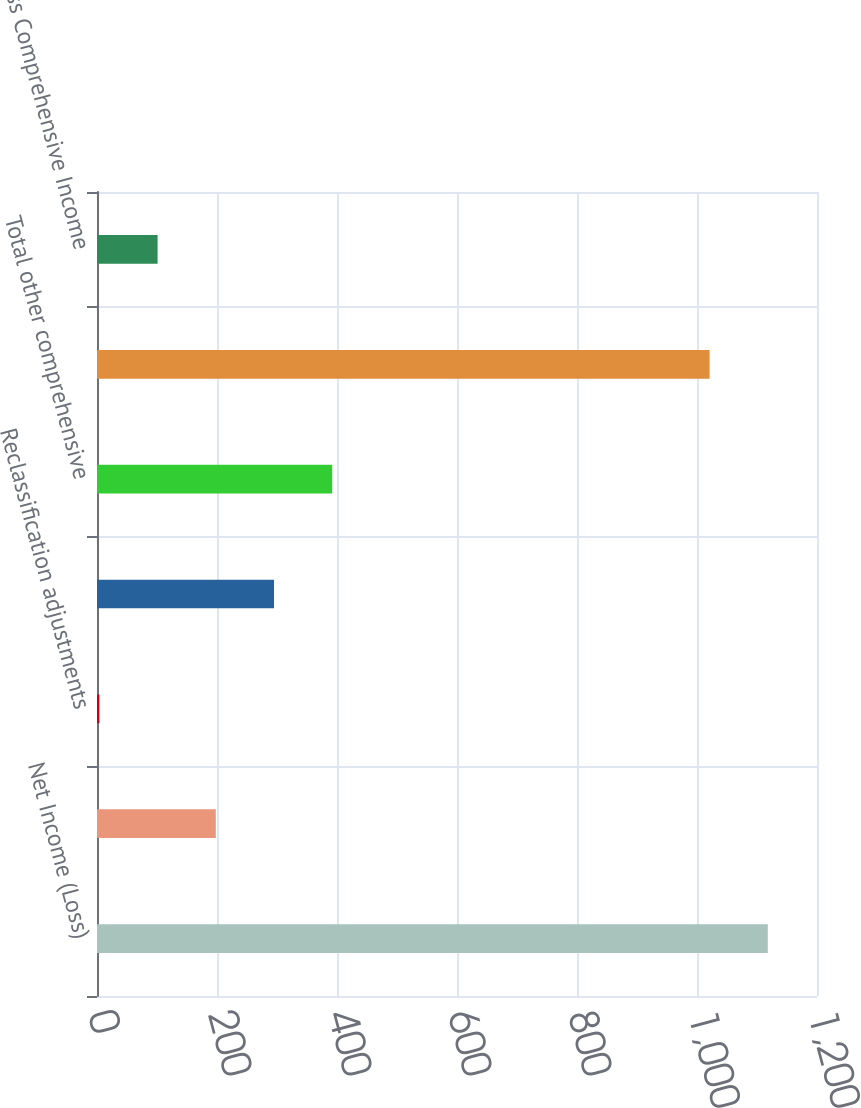Convert chart. <chart><loc_0><loc_0><loc_500><loc_500><bar_chart><fcel>Net Income (Loss)<fcel>Unrealized net gain (loss) on<fcel>Reclassification adjustments<fcel>Pension and other<fcel>Total other comprehensive<fcel>Comprehensive Income (Loss)<fcel>Less Comprehensive Income<nl><fcel>1118<fcel>198<fcel>4<fcel>295<fcel>392<fcel>1021<fcel>101<nl></chart> 